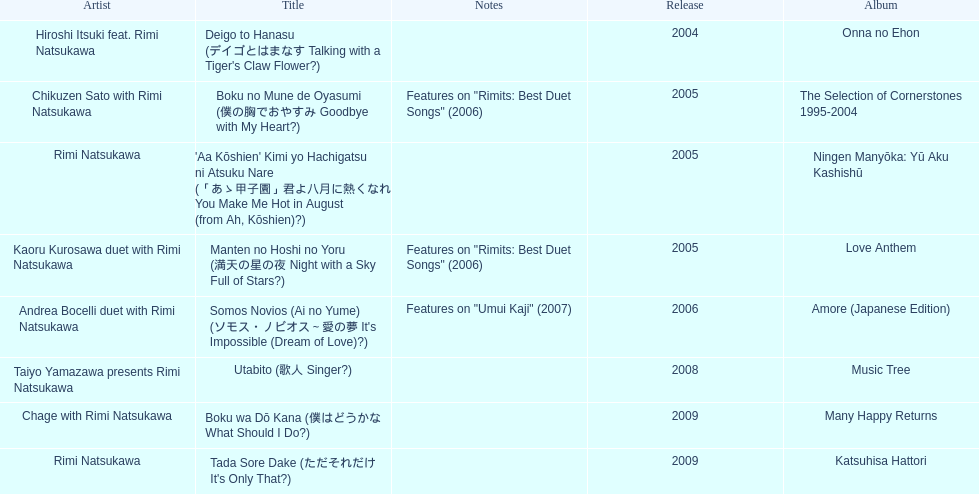Which was not released in 2004, onna no ehon or music tree? Music Tree. 